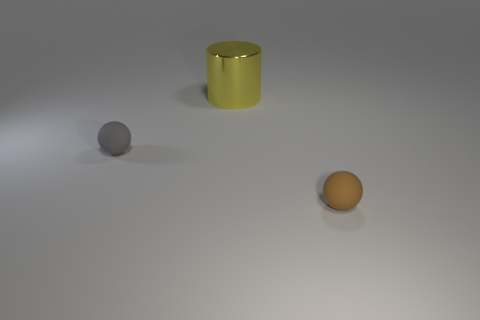Add 1 brown matte things. How many objects exist? 4 Subtract 0 cyan cylinders. How many objects are left? 3 Subtract all cylinders. How many objects are left? 2 Subtract all big cyan metal blocks. Subtract all tiny matte balls. How many objects are left? 1 Add 1 matte balls. How many matte balls are left? 3 Add 3 small brown balls. How many small brown balls exist? 4 